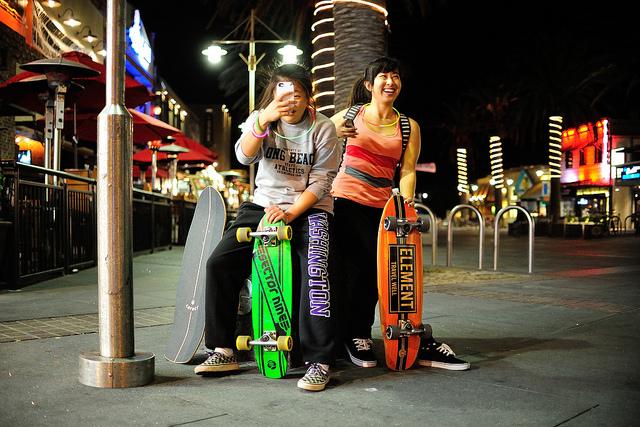What corner are they on?
Answer briefly. Street. Who is taking a picture?
Answer briefly. Person on left. Do they have skateboards?
Answer briefly. Yes. 